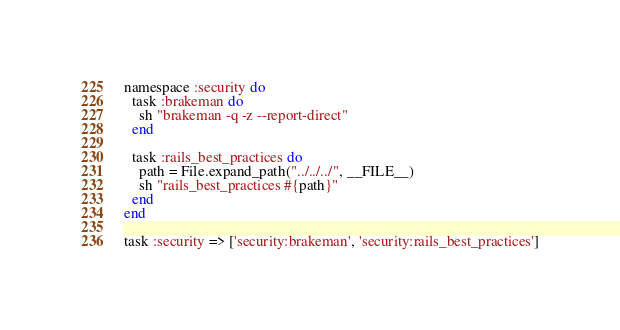<code> <loc_0><loc_0><loc_500><loc_500><_Ruby_>namespace :security do
  task :brakeman do
    sh "brakeman -q -z --report-direct"
  end

  task :rails_best_practices do
    path = File.expand_path("../../../", __FILE__)
    sh "rails_best_practices #{path}"
  end
end

task :security => ['security:brakeman', 'security:rails_best_practices']
</code> 